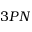<formula> <loc_0><loc_0><loc_500><loc_500>3 P N</formula> 